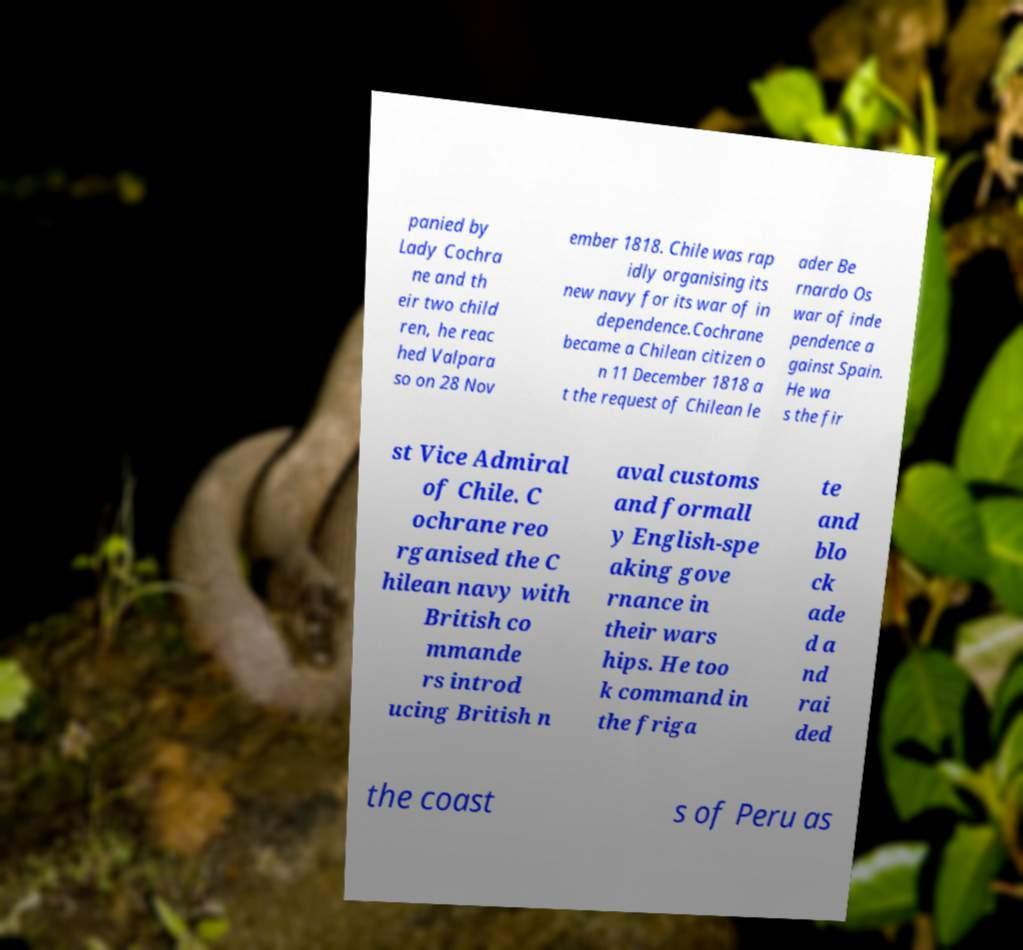Please identify and transcribe the text found in this image. panied by Lady Cochra ne and th eir two child ren, he reac hed Valpara so on 28 Nov ember 1818. Chile was rap idly organising its new navy for its war of in dependence.Cochrane became a Chilean citizen o n 11 December 1818 a t the request of Chilean le ader Be rnardo Os war of inde pendence a gainst Spain. He wa s the fir st Vice Admiral of Chile. C ochrane reo rganised the C hilean navy with British co mmande rs introd ucing British n aval customs and formall y English-spe aking gove rnance in their wars hips. He too k command in the friga te and blo ck ade d a nd rai ded the coast s of Peru as 